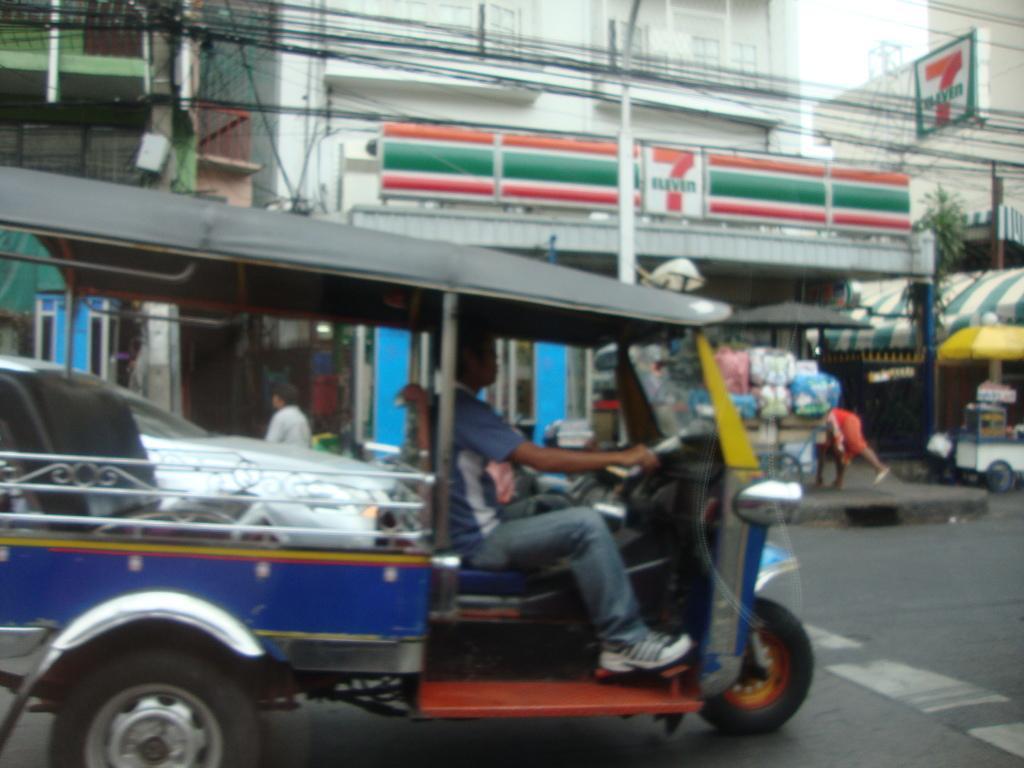In one or two sentences, can you explain what this image depicts? In the image there is a vehicle on the road. Behind the vehicle there are few buildings with walls, store with name boards. In front of the building on the footpath many items on it. In the background there are wires, name boards, roof and a yellow umbrella with a cart. 